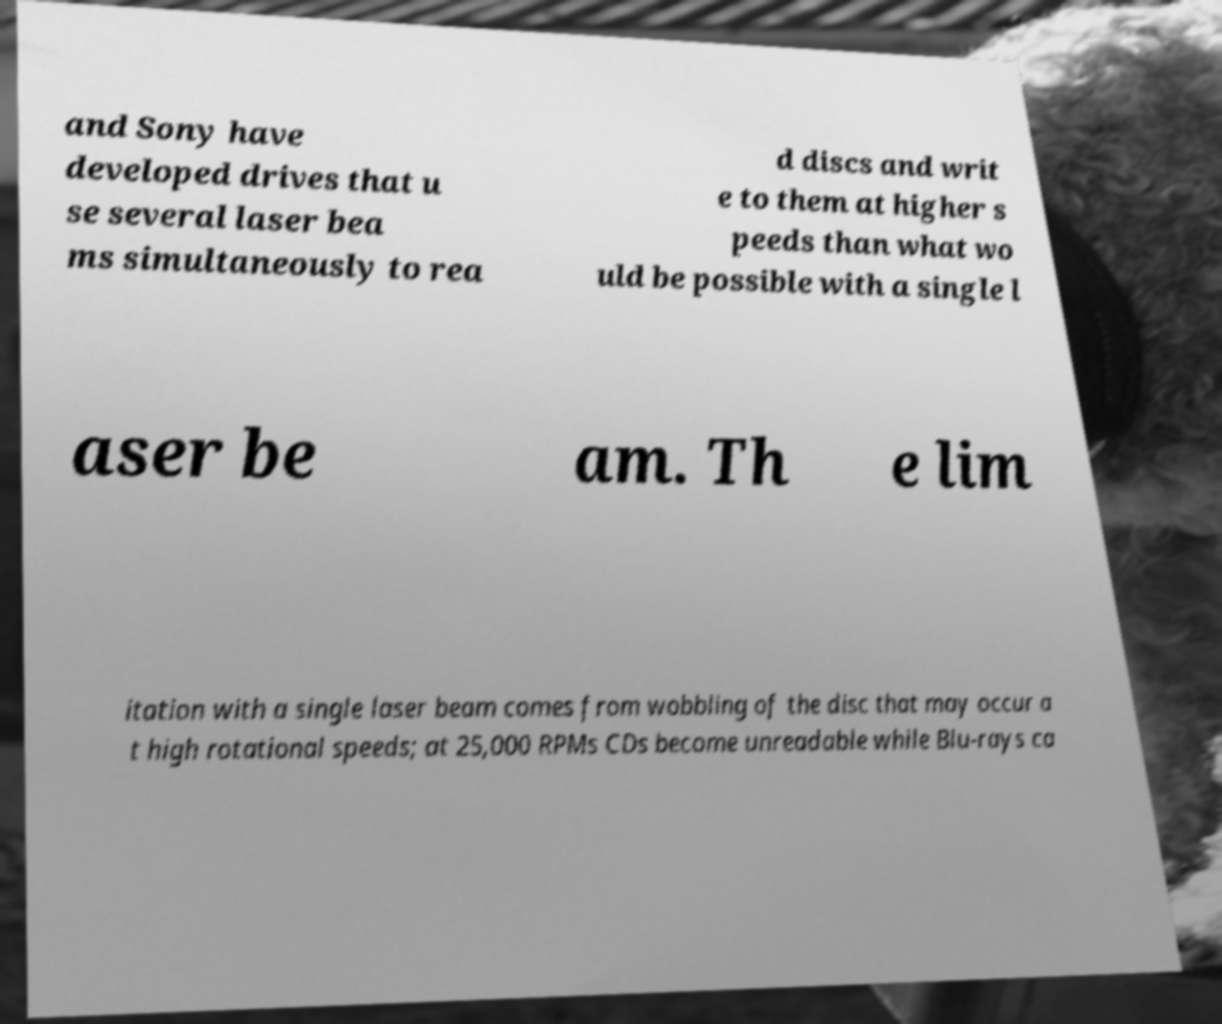Can you accurately transcribe the text from the provided image for me? and Sony have developed drives that u se several laser bea ms simultaneously to rea d discs and writ e to them at higher s peeds than what wo uld be possible with a single l aser be am. Th e lim itation with a single laser beam comes from wobbling of the disc that may occur a t high rotational speeds; at 25,000 RPMs CDs become unreadable while Blu-rays ca 